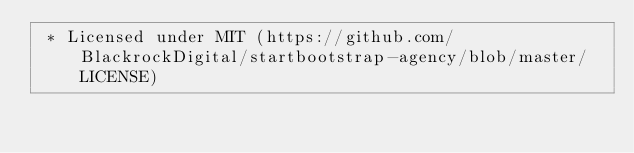Convert code to text. <code><loc_0><loc_0><loc_500><loc_500><_CSS_> * Licensed under MIT (https://github.com/BlackrockDigital/startbootstrap-agency/blob/master/LICENSE)</code> 